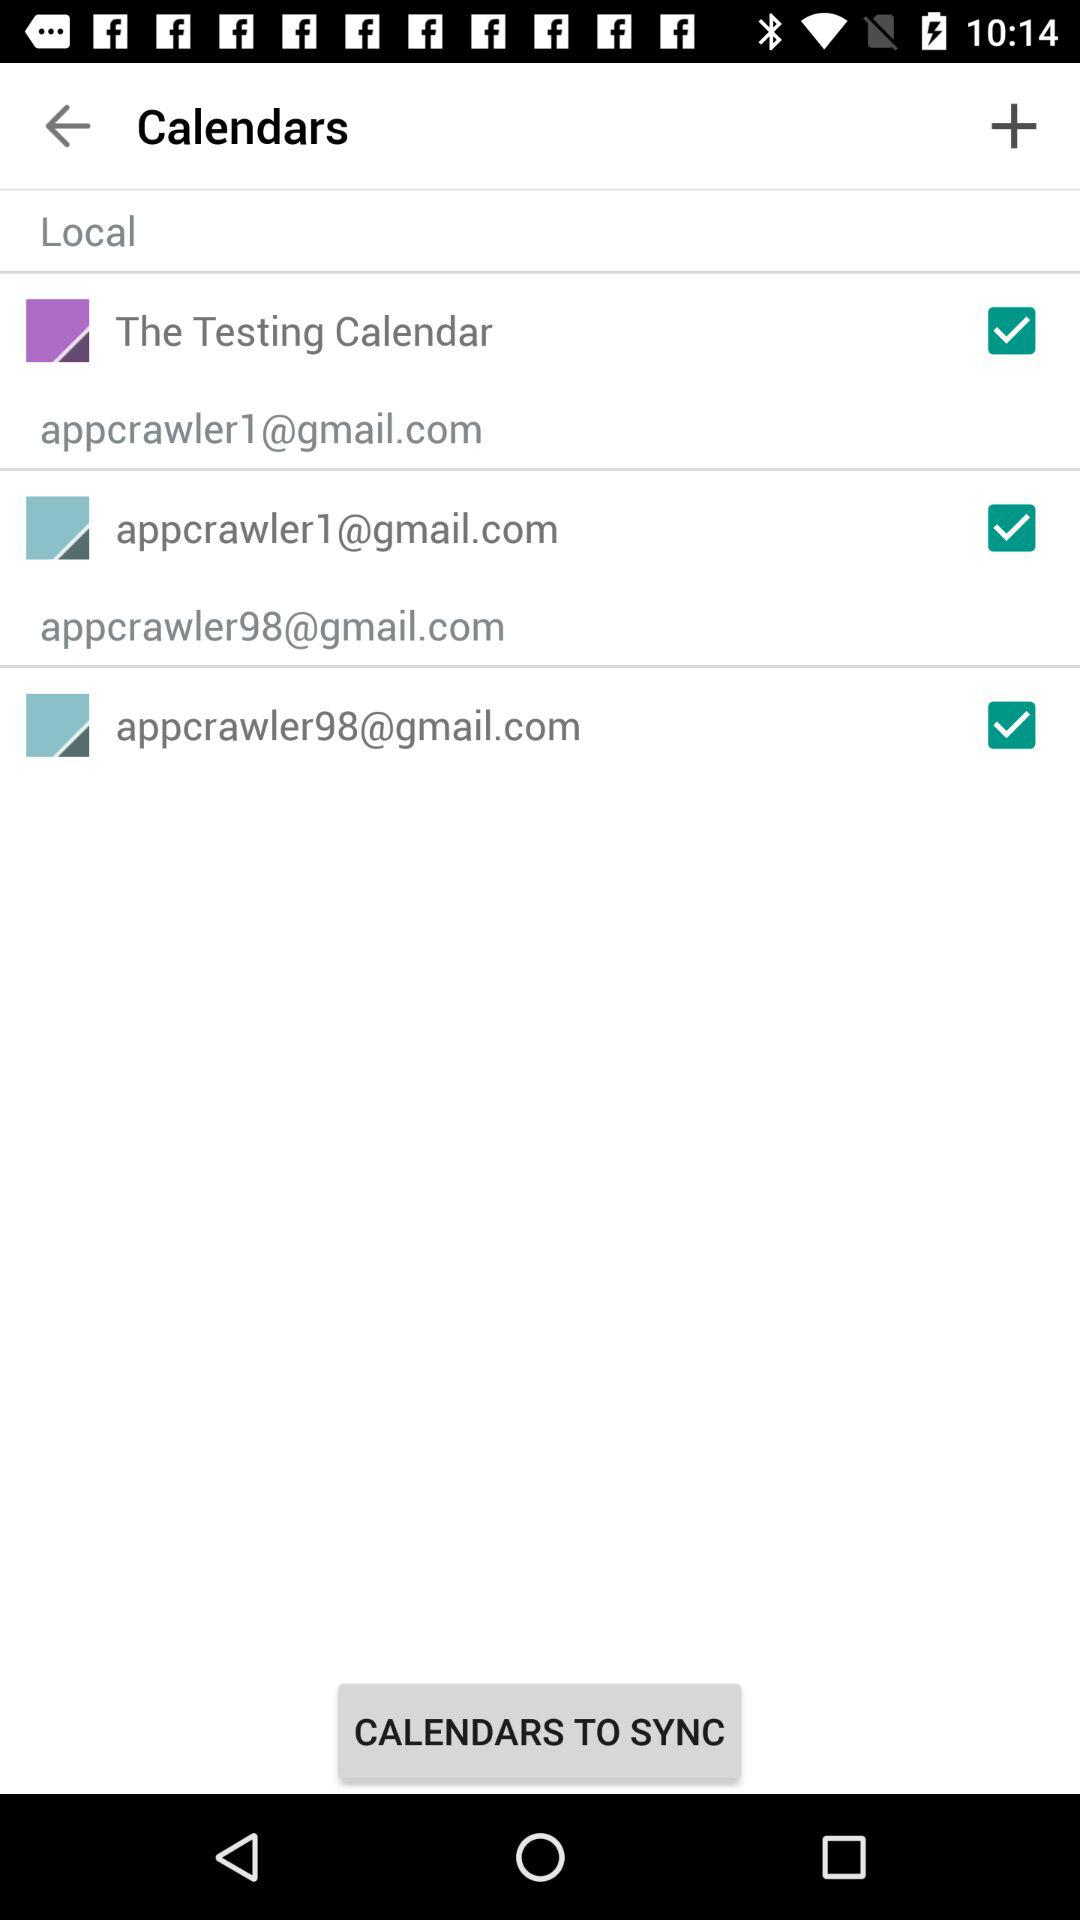How many calendars are present in the All calendars section?
Answer the question using a single word or phrase. 3 